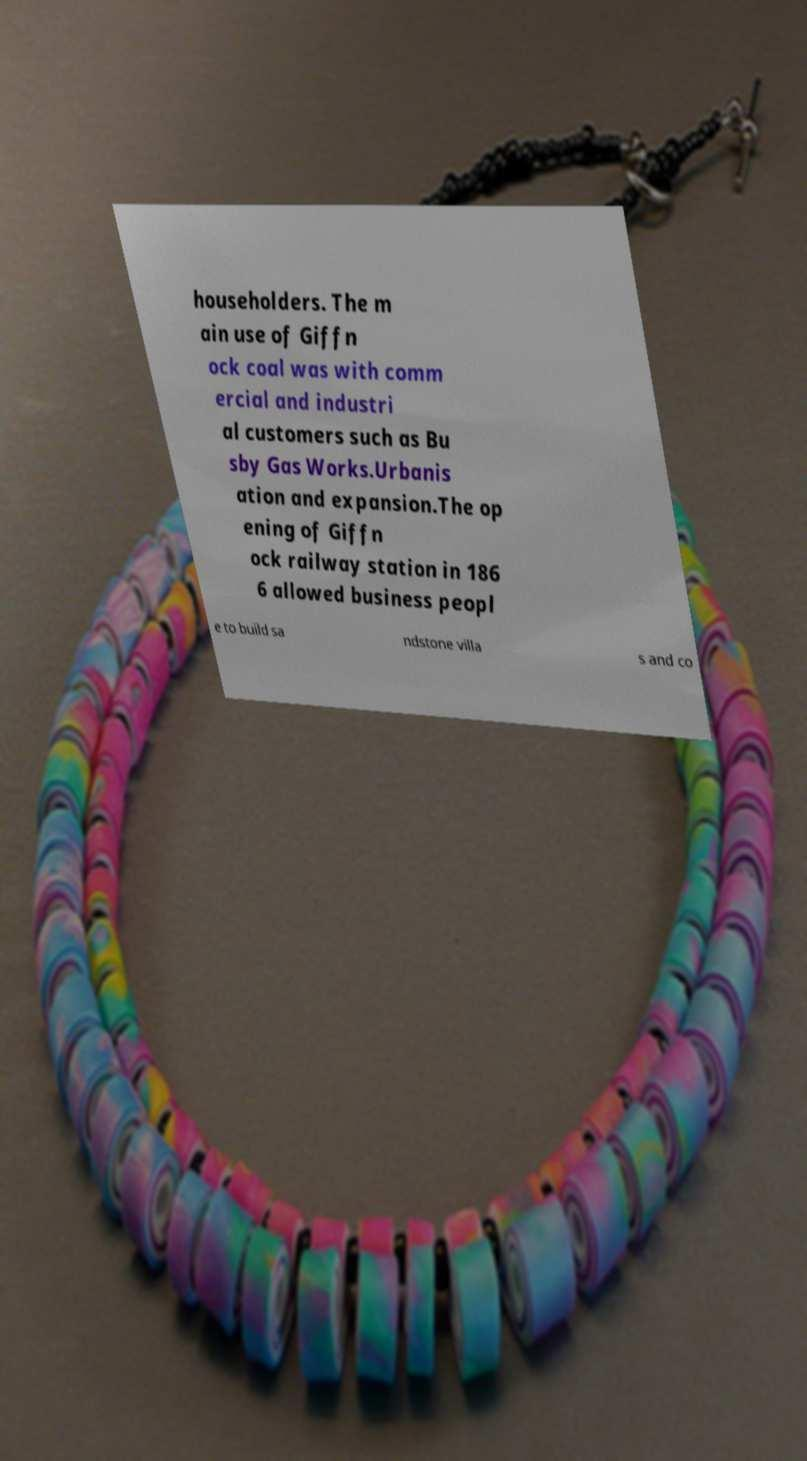Please identify and transcribe the text found in this image. householders. The m ain use of Giffn ock coal was with comm ercial and industri al customers such as Bu sby Gas Works.Urbanis ation and expansion.The op ening of Giffn ock railway station in 186 6 allowed business peopl e to build sa ndstone villa s and co 